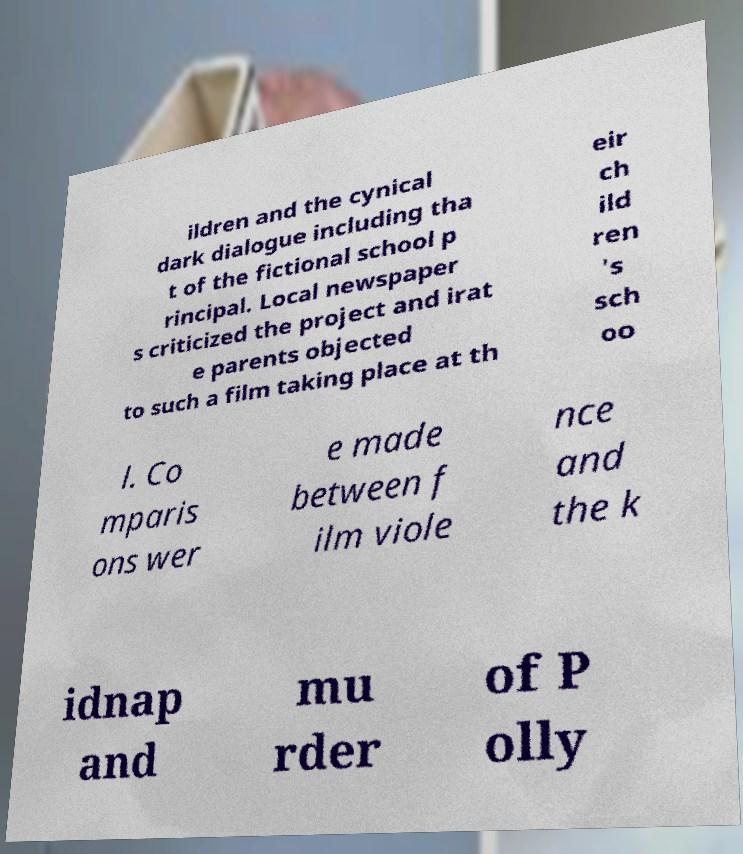What messages or text are displayed in this image? I need them in a readable, typed format. ildren and the cynical dark dialogue including tha t of the fictional school p rincipal. Local newspaper s criticized the project and irat e parents objected to such a film taking place at th eir ch ild ren 's sch oo l. Co mparis ons wer e made between f ilm viole nce and the k idnap and mu rder of P olly 